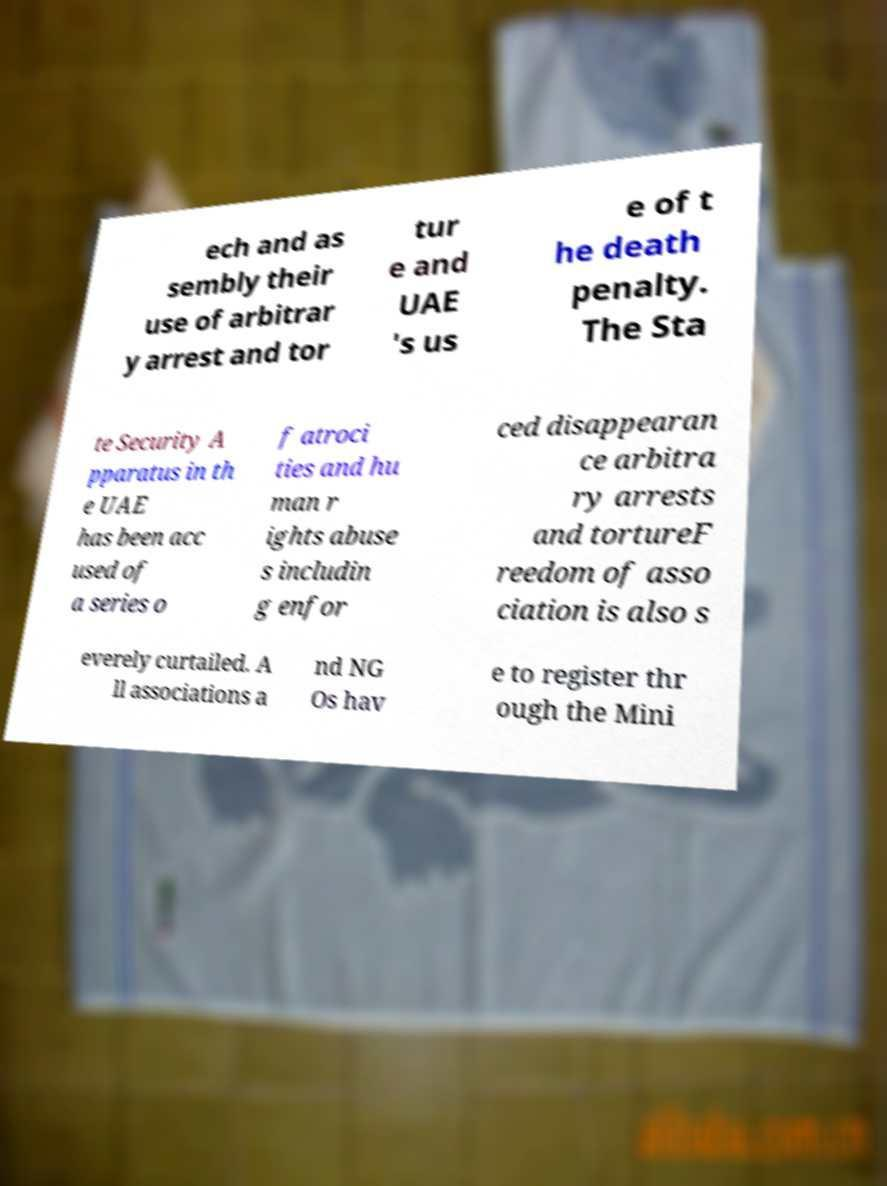What messages or text are displayed in this image? I need them in a readable, typed format. ech and as sembly their use of arbitrar y arrest and tor tur e and UAE 's us e of t he death penalty. The Sta te Security A pparatus in th e UAE has been acc used of a series o f atroci ties and hu man r ights abuse s includin g enfor ced disappearan ce arbitra ry arrests and tortureF reedom of asso ciation is also s everely curtailed. A ll associations a nd NG Os hav e to register thr ough the Mini 